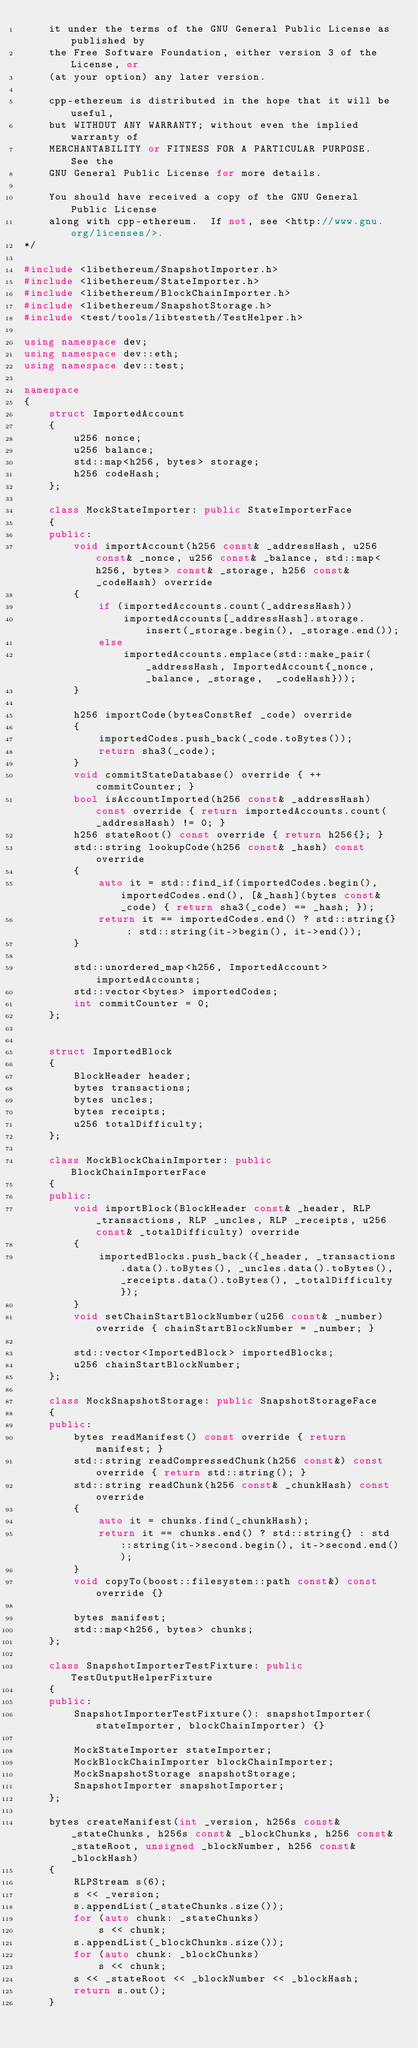<code> <loc_0><loc_0><loc_500><loc_500><_C++_>	it under the terms of the GNU General Public License as published by
	the Free Software Foundation, either version 3 of the License, or
	(at your option) any later version.

	cpp-ethereum is distributed in the hope that it will be useful,
	but WITHOUT ANY WARRANTY; without even the implied warranty of
	MERCHANTABILITY or FITNESS FOR A PARTICULAR PURPOSE.  See the
	GNU General Public License for more details.

	You should have received a copy of the GNU General Public License
	along with cpp-ethereum.  If not, see <http://www.gnu.org/licenses/>.
*/

#include <libethereum/SnapshotImporter.h>
#include <libethereum/StateImporter.h>
#include <libethereum/BlockChainImporter.h>
#include <libethereum/SnapshotStorage.h>
#include <test/tools/libtesteth/TestHelper.h>

using namespace dev;
using namespace dev::eth;
using namespace dev::test;

namespace
{
	struct ImportedAccount
	{
		u256 nonce;
		u256 balance;
		std::map<h256, bytes> storage;
		h256 codeHash;
	};

	class MockStateImporter: public StateImporterFace
	{
	public:
		void importAccount(h256 const& _addressHash, u256 const& _nonce, u256 const& _balance, std::map<h256, bytes> const& _storage, h256 const& _codeHash) override
		{
			if (importedAccounts.count(_addressHash))
				importedAccounts[_addressHash].storage.insert(_storage.begin(), _storage.end());
			else
				importedAccounts.emplace(std::make_pair(_addressHash, ImportedAccount{_nonce, _balance, _storage,  _codeHash}));
		}

		h256 importCode(bytesConstRef _code) override
		{ 
			importedCodes.push_back(_code.toBytes());
			return sha3(_code);
		}
		void commitStateDatabase() override { ++commitCounter; }
		bool isAccountImported(h256 const& _addressHash) const override { return importedAccounts.count(_addressHash) != 0; }
		h256 stateRoot() const override { return h256{}; }
		std::string lookupCode(h256 const& _hash) const override
		{ 
			auto it = std::find_if(importedCodes.begin(), importedCodes.end(), [&_hash](bytes const& _code) { return sha3(_code) == _hash; });
			return it == importedCodes.end() ? std::string{} : std::string(it->begin(), it->end());
		}

		std::unordered_map<h256, ImportedAccount> importedAccounts;
		std::vector<bytes> importedCodes;
		int commitCounter = 0;
	};


	struct ImportedBlock
	{
		BlockHeader header;
		bytes transactions;
		bytes uncles;
		bytes receipts;
		u256 totalDifficulty;
	};

	class MockBlockChainImporter: public BlockChainImporterFace
	{
	public:
		void importBlock(BlockHeader const& _header, RLP _transactions, RLP _uncles, RLP _receipts, u256 const& _totalDifficulty) override
		{
			importedBlocks.push_back({_header, _transactions.data().toBytes(), _uncles.data().toBytes(), _receipts.data().toBytes(), _totalDifficulty});
		}
		void setChainStartBlockNumber(u256 const& _number) override { chainStartBlockNumber = _number; }

		std::vector<ImportedBlock> importedBlocks;
		u256 chainStartBlockNumber;
	};

	class MockSnapshotStorage: public SnapshotStorageFace
	{
	public:
		bytes readManifest() const override { return manifest; }
        std::string readCompressedChunk(h256 const&) const override { return std::string(); }
        std::string readChunk(h256 const& _chunkHash) const override
		{ 
			auto it = chunks.find(_chunkHash);
			return it == chunks.end() ? std::string{} : std::string(it->second.begin(), it->second.end());
		}
        void copyTo(boost::filesystem::path const&) const override {}

        bytes manifest;
		std::map<h256, bytes> chunks;
	};

	class SnapshotImporterTestFixture: public TestOutputHelperFixture
	{
	public:
		SnapshotImporterTestFixture(): snapshotImporter(stateImporter, blockChainImporter) {}

		MockStateImporter stateImporter;
		MockBlockChainImporter blockChainImporter;
		MockSnapshotStorage snapshotStorage;
		SnapshotImporter snapshotImporter;
	};

	bytes createManifest(int _version, h256s const& _stateChunks, h256s const& _blockChunks, h256 const& _stateRoot, unsigned _blockNumber, h256 const& _blockHash)
	{
		RLPStream s(6);
		s << _version;
		s.appendList(_stateChunks.size());
		for (auto chunk: _stateChunks)
			s << chunk;
		s.appendList(_blockChunks.size());
		for (auto chunk: _blockChunks)
			s << chunk;
		s << _stateRoot << _blockNumber << _blockHash;
		return s.out();
	}
</code> 